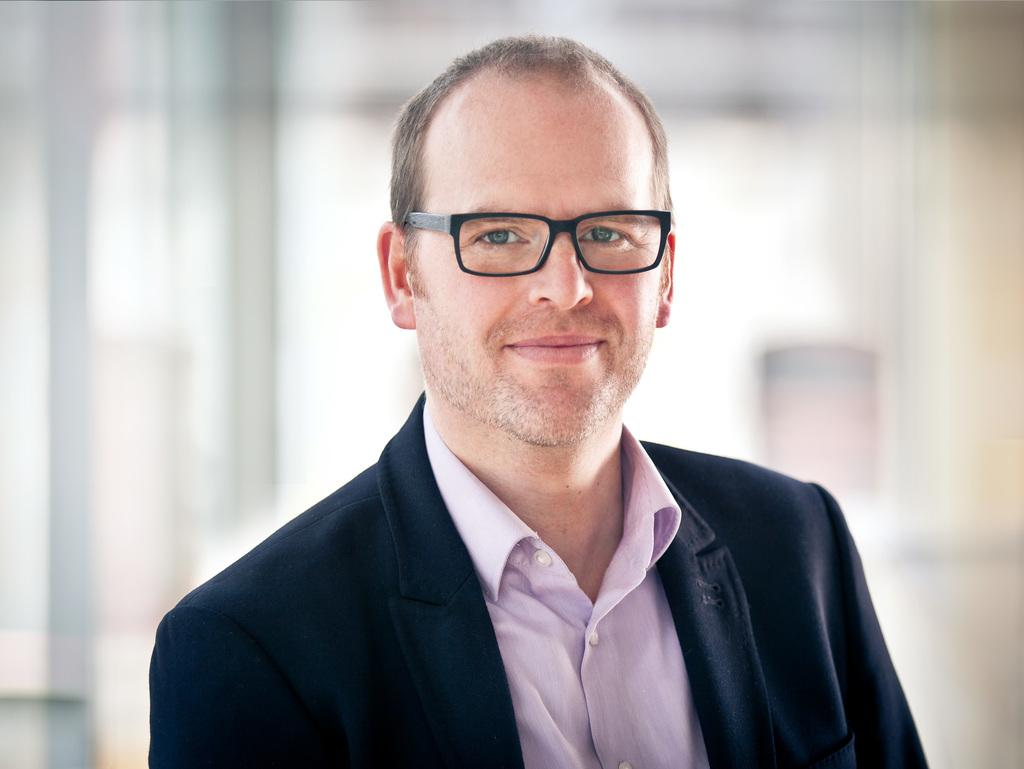What is the main subject of the picture? The main subject of the picture is a man. What is the man wearing on his upper body? The man is wearing a blazer and a purple shirt. What accessory does the man have on his face? The man has spectacles. What is the man's facial expression in the picture? The man is smiling. Can you describe the background of the image? The backdrop of the image is blurred. What type of cable is being used by the man in the image? There is no cable visible in the image; the man is not using any cable. What color is the powder that the man is holding in the image? There is no powder present in the image; the man is not holding any powder. 